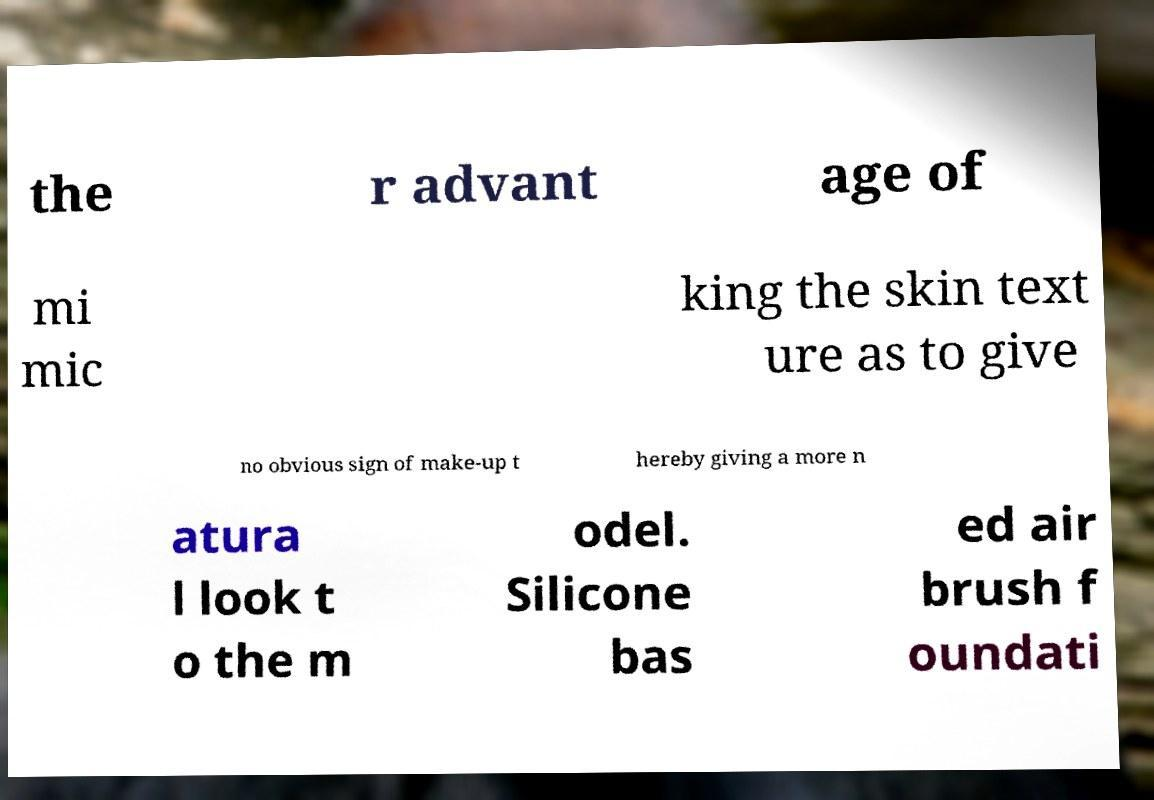What messages or text are displayed in this image? I need them in a readable, typed format. the r advant age of mi mic king the skin text ure as to give no obvious sign of make-up t hereby giving a more n atura l look t o the m odel. Silicone bas ed air brush f oundati 